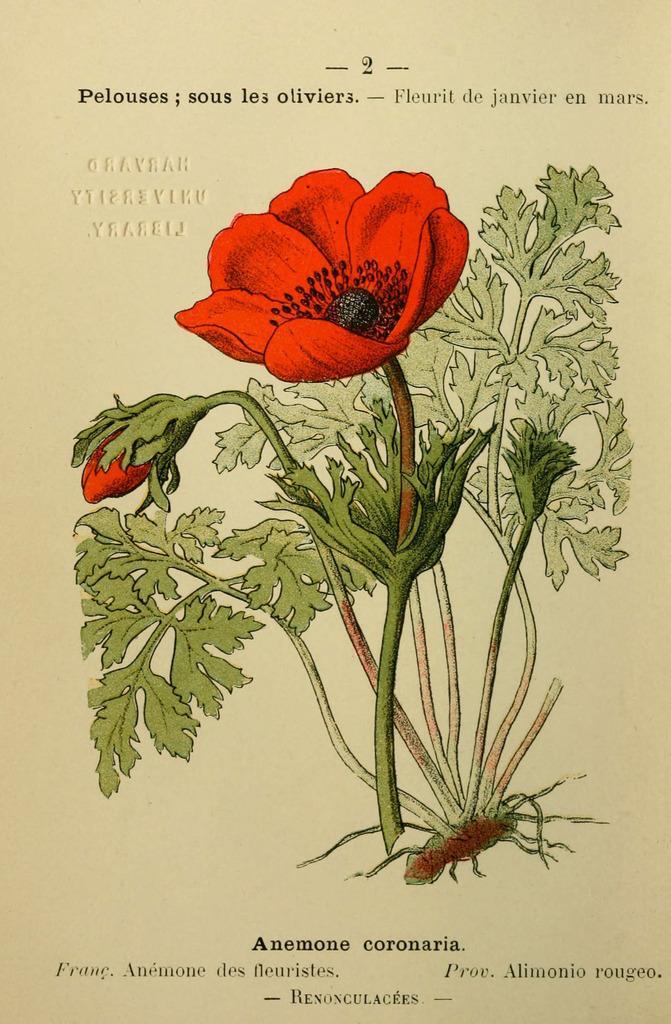Could you give a brief overview of what you see in this image? In the picture I can see painting of flowers and plants. The flowers are red in color. I can also see something written on the image. 